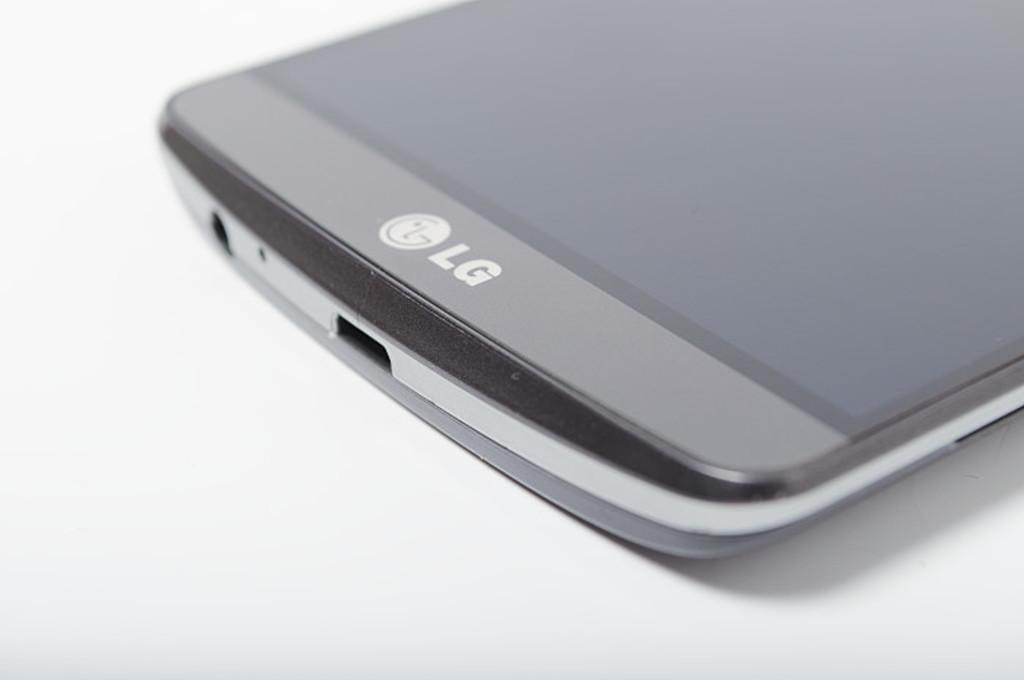What brand of phone is this?
Your response must be concise. Lg. 